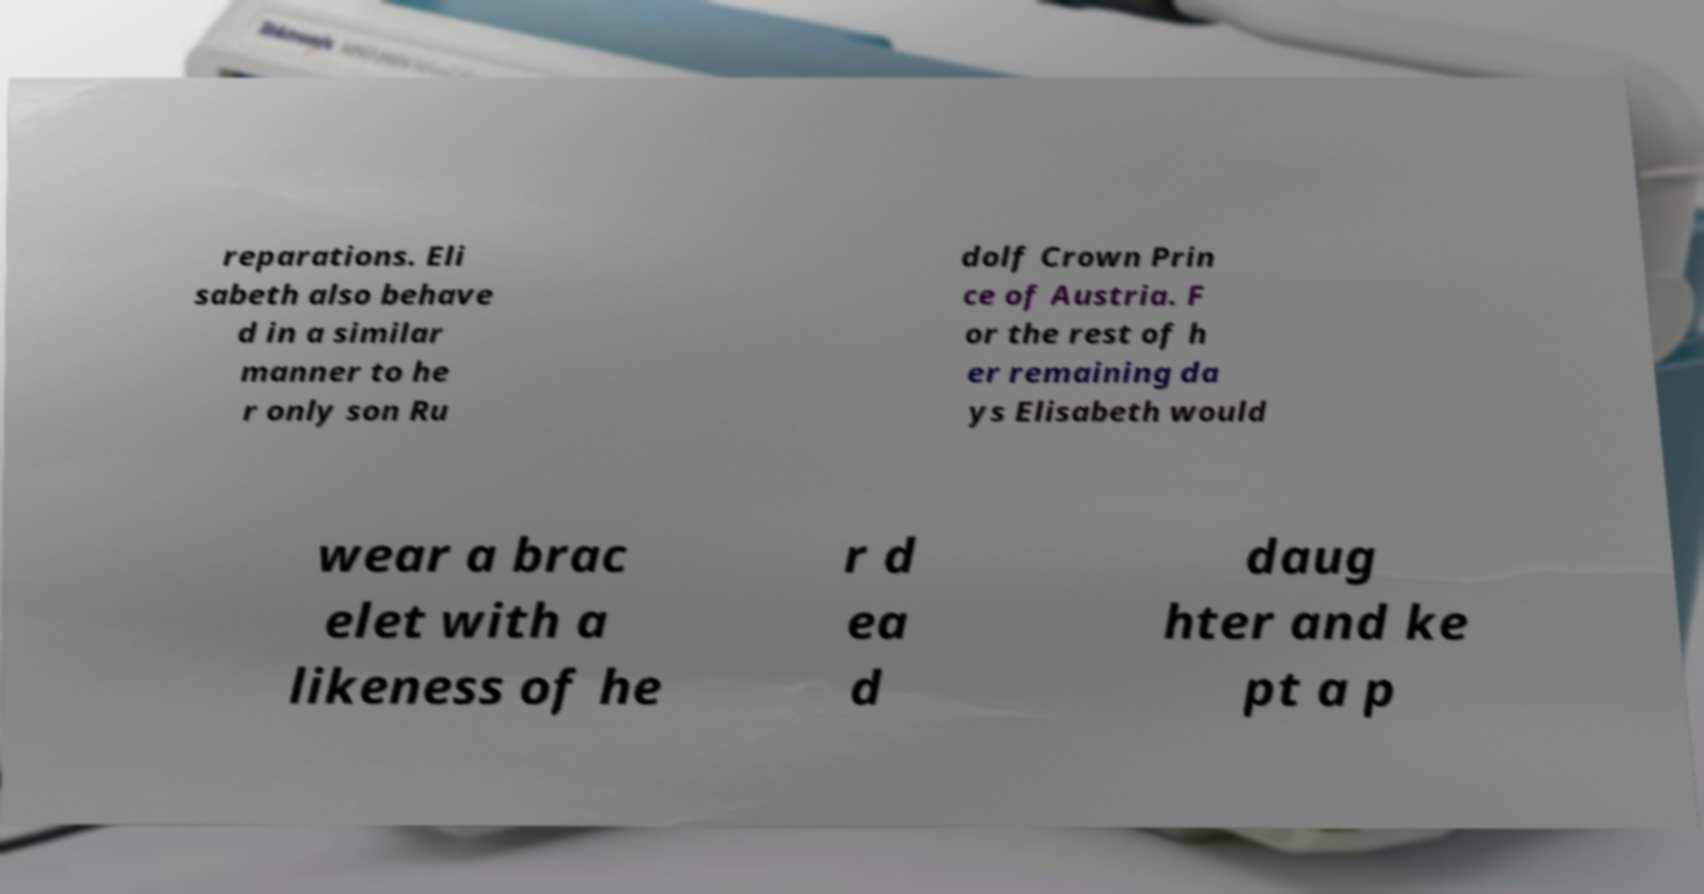There's text embedded in this image that I need extracted. Can you transcribe it verbatim? reparations. Eli sabeth also behave d in a similar manner to he r only son Ru dolf Crown Prin ce of Austria. F or the rest of h er remaining da ys Elisabeth would wear a brac elet with a likeness of he r d ea d daug hter and ke pt a p 